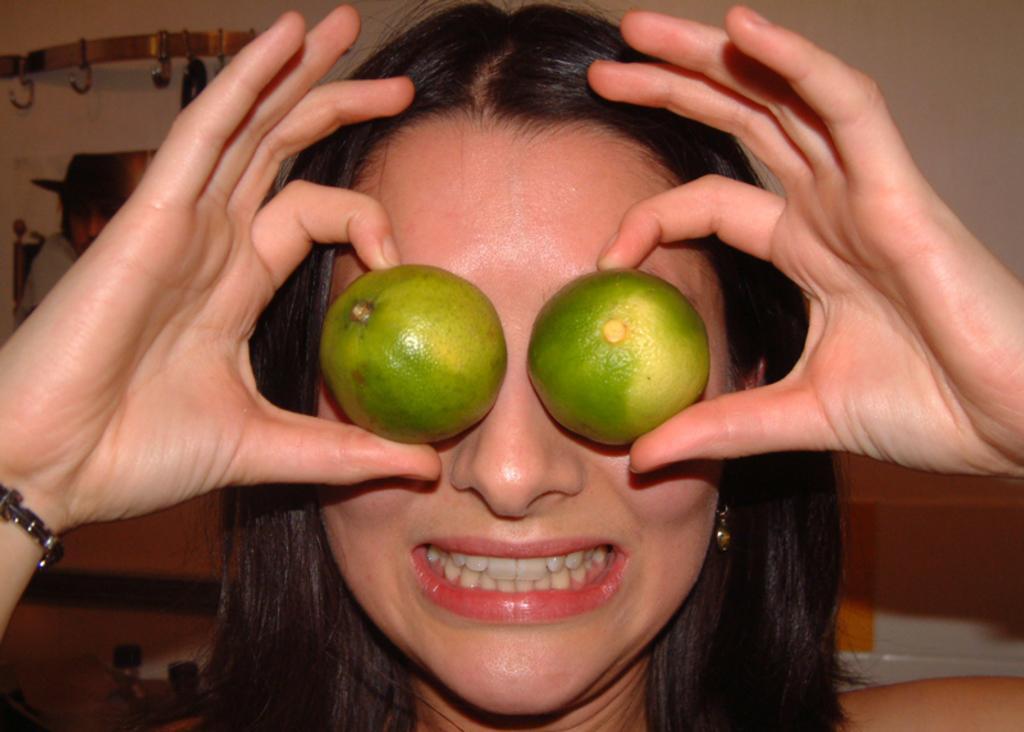Could you give a brief overview of what you see in this image? In this image in the front there is a woman holding fruits in her hand and smiling. In the background there is a wall and on the wall there is a stand and there is an object which is black in colour and on the object there is a cloth which is grey in colour. 